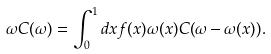<formula> <loc_0><loc_0><loc_500><loc_500>\omega C ( \omega ) = \int _ { 0 } ^ { 1 } d x f ( x ) \omega ( x ) C ( \omega - \omega ( x ) ) .</formula> 